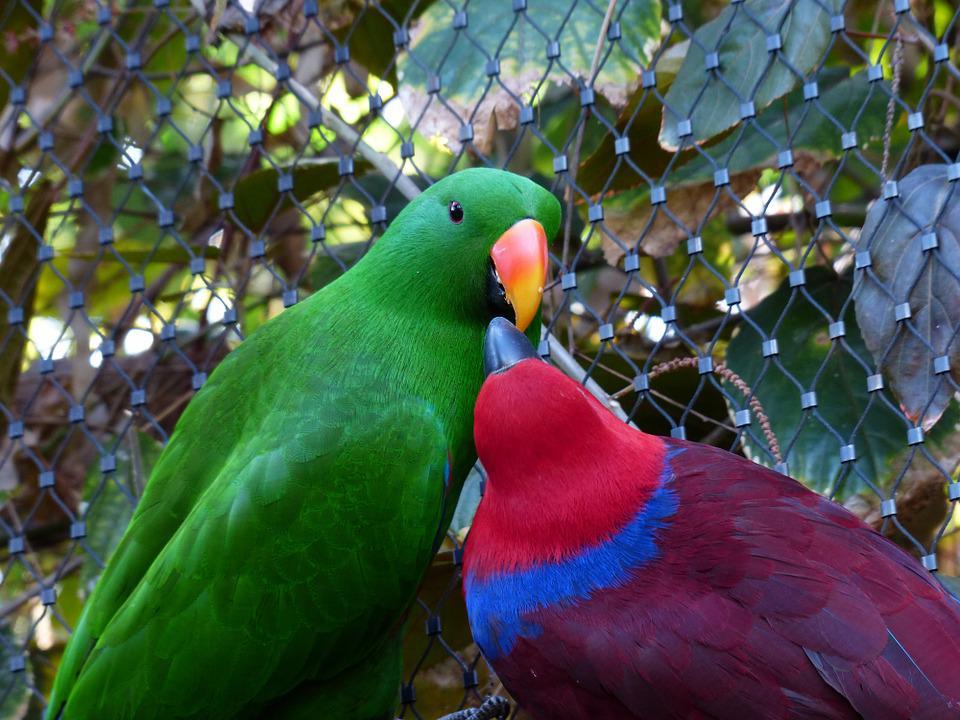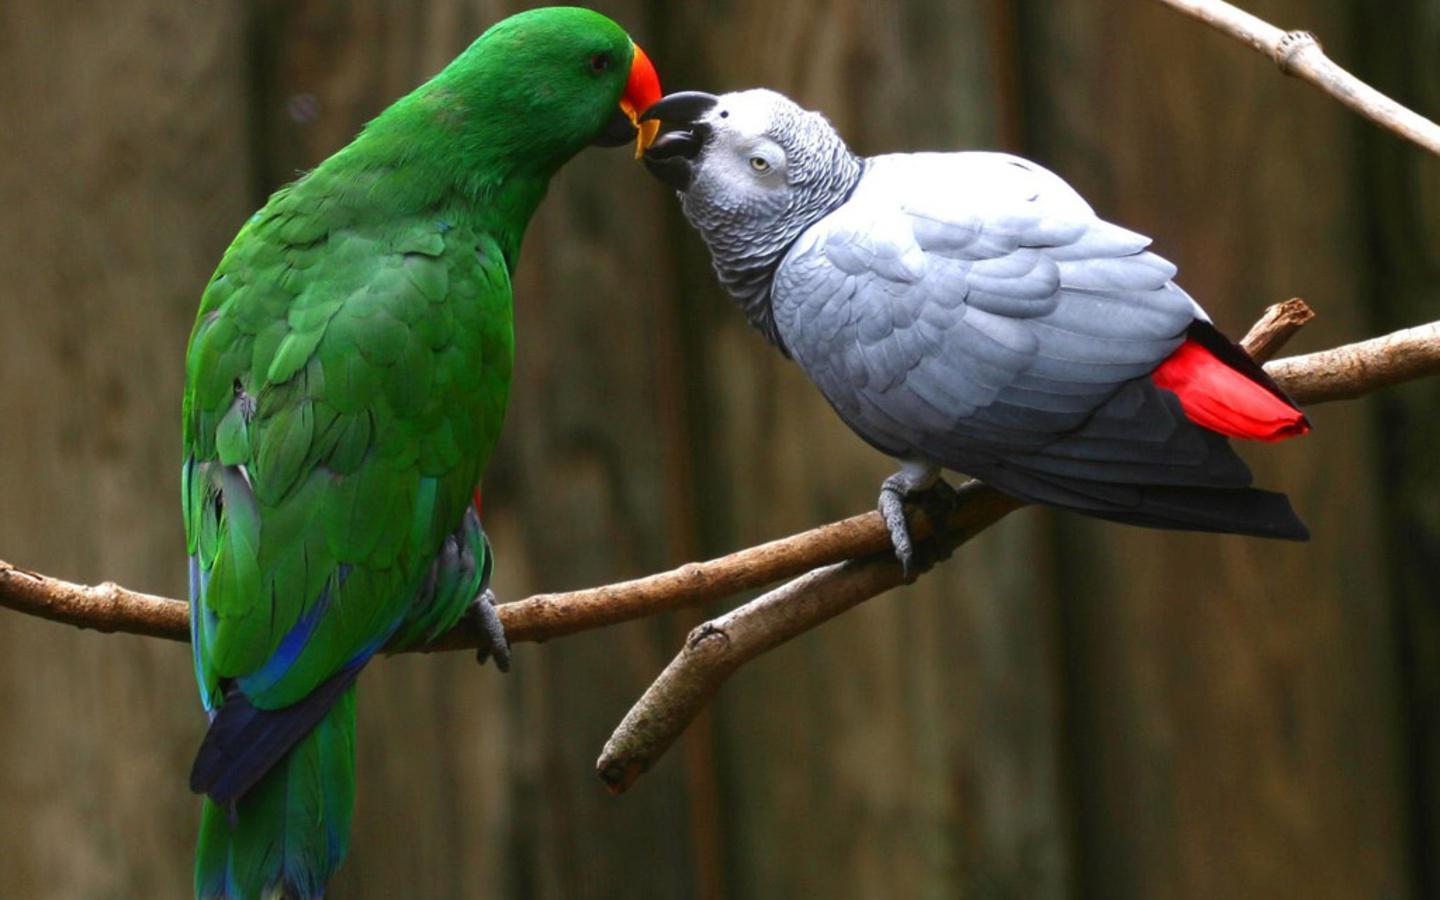The first image is the image on the left, the second image is the image on the right. For the images shown, is this caption "Parrots in the right and left images share the same coloration or colorations." true? Answer yes or no. No. 